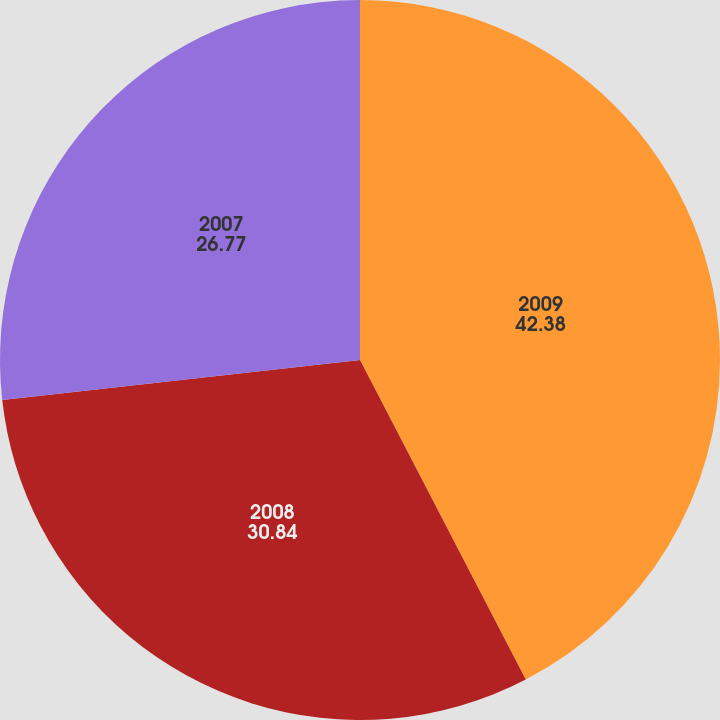<chart> <loc_0><loc_0><loc_500><loc_500><pie_chart><fcel>2009<fcel>2008<fcel>2007<nl><fcel>42.38%<fcel>30.84%<fcel>26.77%<nl></chart> 